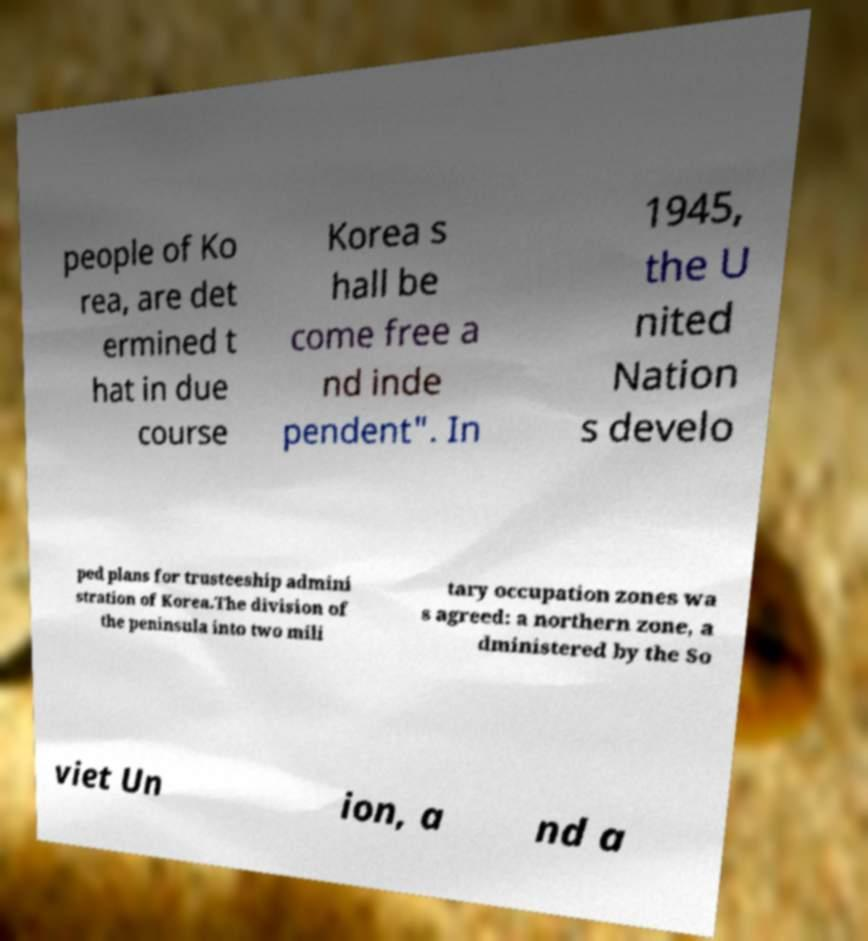I need the written content from this picture converted into text. Can you do that? people of Ko rea, are det ermined t hat in due course Korea s hall be come free a nd inde pendent". In 1945, the U nited Nation s develo ped plans for trusteeship admini stration of Korea.The division of the peninsula into two mili tary occupation zones wa s agreed: a northern zone, a dministered by the So viet Un ion, a nd a 